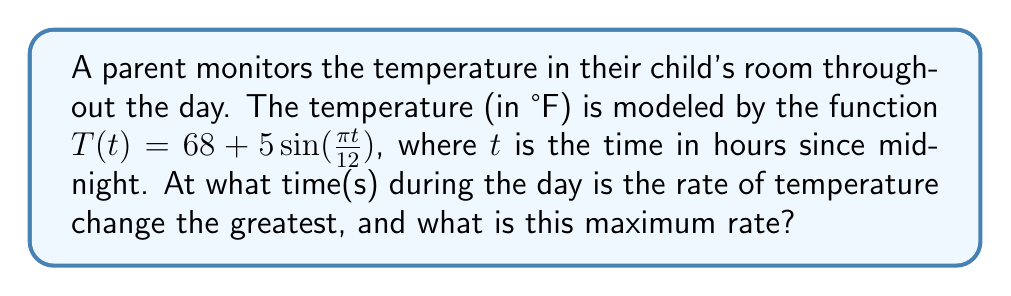What is the answer to this math problem? To solve this problem, we need to follow these steps:

1) The rate of temperature change is given by the derivative of $T(t)$. Let's find $T'(t)$:

   $T'(t) = 5 \cdot \frac{\pi}{12} \cos(\frac{\pi t}{12}) = \frac{5\pi}{12} \cos(\frac{\pi t}{12})$

2) The rate of change will be greatest when $|T'(t)|$ is at its maximum. The maximum of $|cos(x)|$ is 1, which occurs when $x = 0, \pi, 2\pi,$ etc.

3) So, we need to solve:

   $\frac{\pi t}{12} = 0, \pi, 2\pi$

4) Solving these equations:
   
   For $\frac{\pi t}{12} = 0$: $t = 0$ (midnight)
   
   For $\frac{\pi t}{12} = \pi$: $t = 12$ (noon)
   
   For $\frac{\pi t}{12} = 2\pi$: $t = 24$ (midnight of the next day)

5) The maximum rate of change occurs at these times, and it's the absolute value of $T'(t)$ when $\cos(\frac{\pi t}{12}) = \pm 1$:

   $|T'(t)_{max}| = |\frac{5\pi}{12}| \approx 1.31$ °F/hour

Therefore, the rate of temperature change is greatest at midnight and noon, with a maximum rate of about 1.31 °F per hour.
Answer: Midnight and noon; $\frac{5\pi}{12}$ °F/hour 